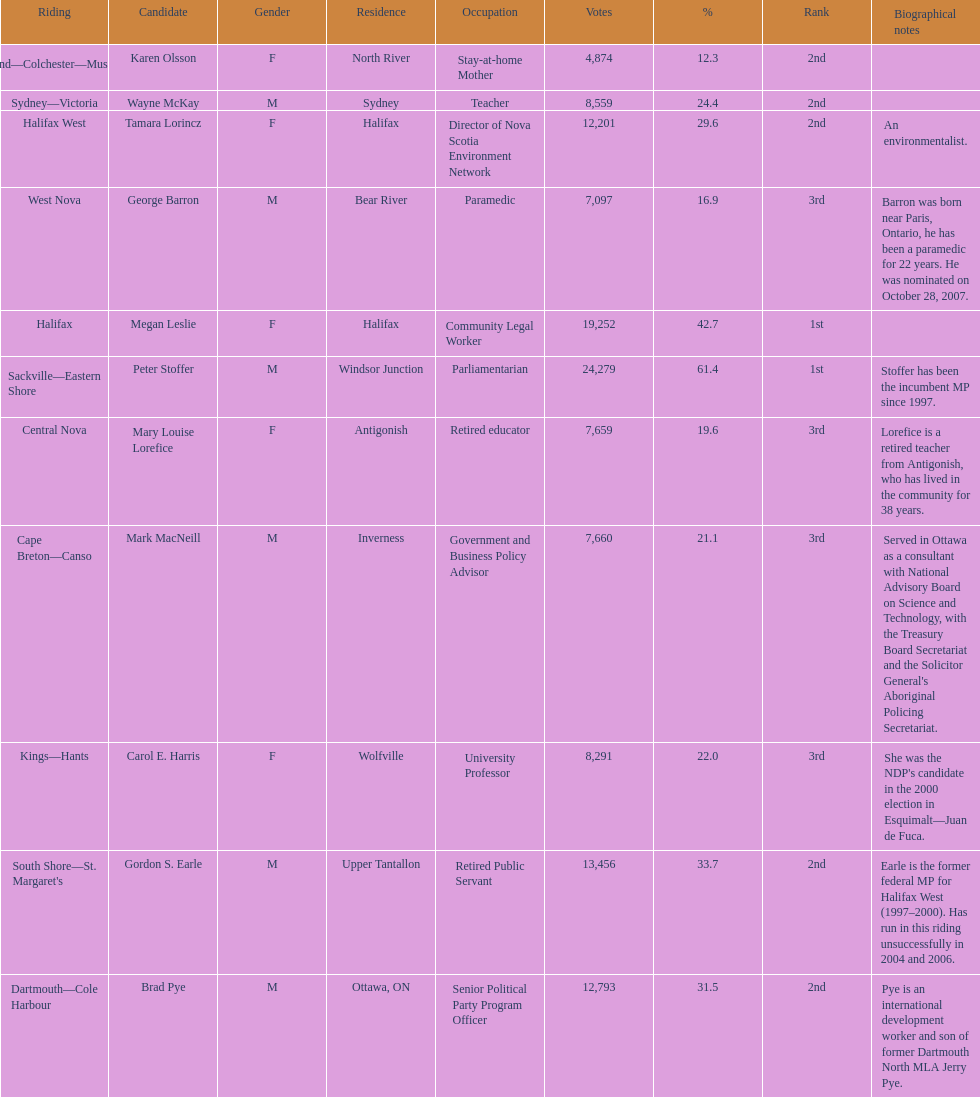How many candidates were from halifax? 2. 